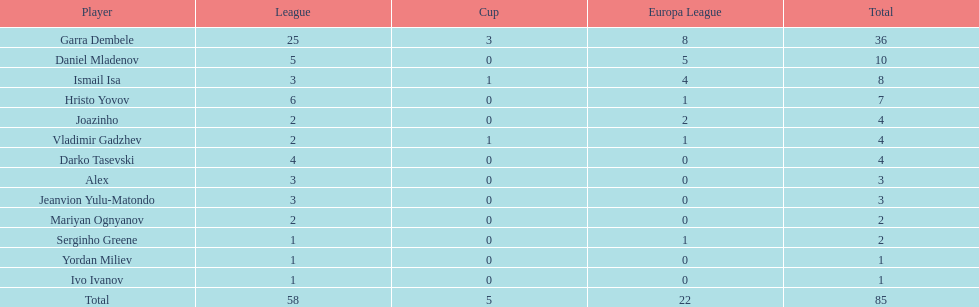Which is the only player from germany? Jeanvion Yulu-Matondo. 